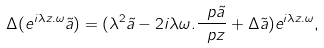<formula> <loc_0><loc_0><loc_500><loc_500>\Delta ( e ^ { i \lambda z . \omega } \tilde { a } ) = ( \lambda ^ { 2 } \tilde { a } - 2 i \lambda \omega . \frac { \ p \tilde { a } } { \ p z } + \Delta \tilde { a } ) e ^ { i \lambda z . \omega } ,</formula> 